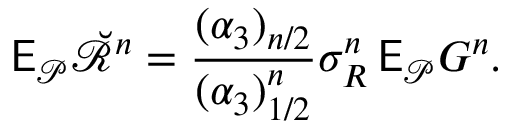<formula> <loc_0><loc_0><loc_500><loc_500>\mathsf E _ { \mathcal { P } } \breve { \ m a t h s c r R } ^ { n } = \frac { ( \alpha _ { 3 } ) _ { n / 2 } } { ( \alpha _ { 3 } ) _ { 1 / 2 } ^ { n } } \sigma _ { R } ^ { n } \, \mathsf E _ { \mathcal { P } } G ^ { n } .</formula> 